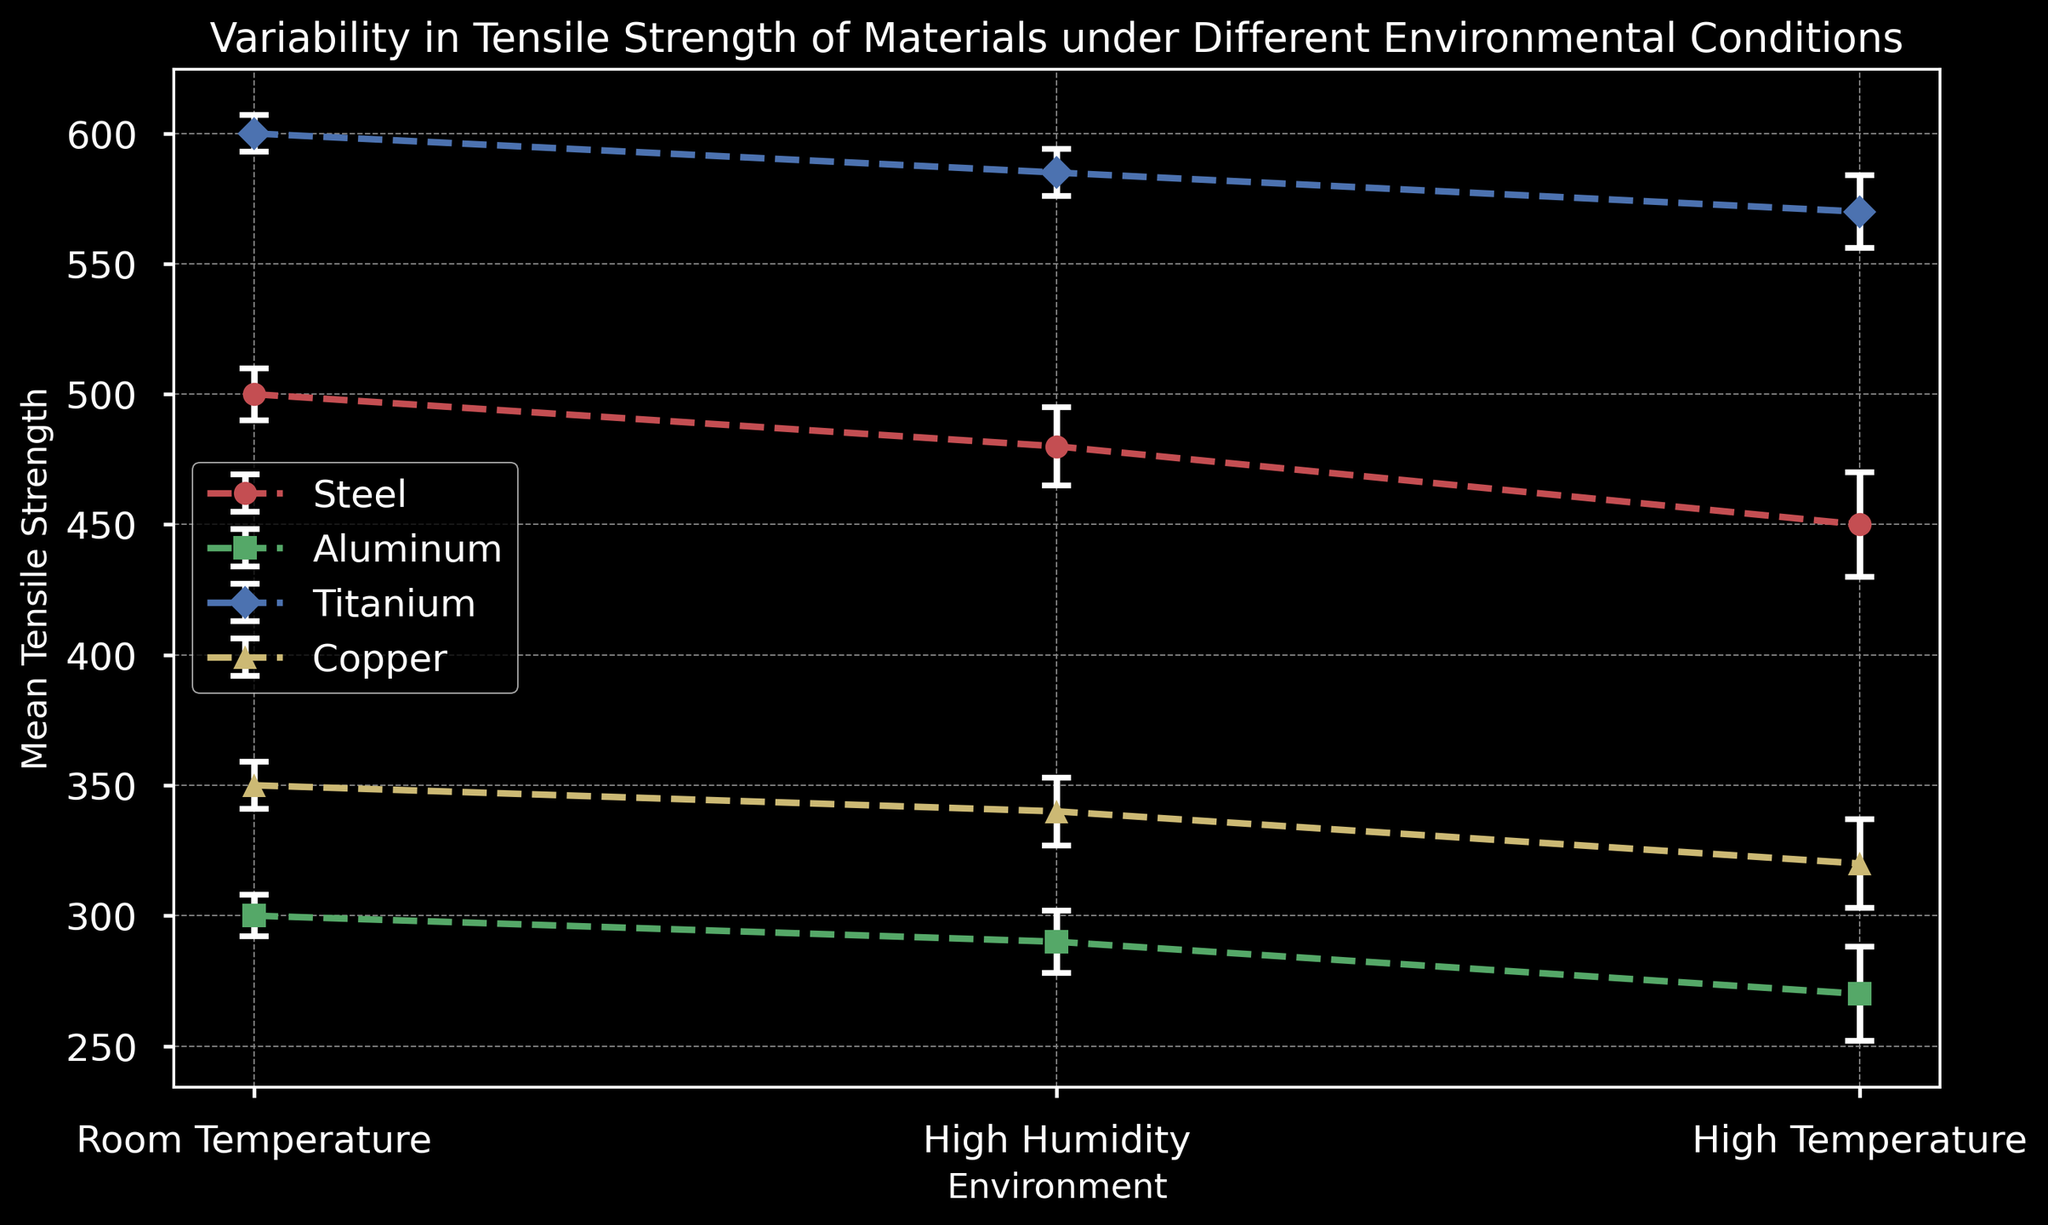What material has the highest variability in tensile strength under high temperature conditions? Variability is measured by the standard deviation. For high temperature conditions: Steel (20), Aluminum (18), Titanium (14), and Copper (17). The material with the highest standard deviation is Steel.
Answer: Steel Which material shows the least drop in mean tensile strength from room temperature to high humidity? Calculate the difference for each material: Steel (500-480=20), Aluminum (300-290=10), Titanium (600-585=15), and Copper (350-340=10). Aluminum and Copper both show the smallest drop of 10.
Answer: Aluminum, Copper Between Steel and Titanium, which material has a higher average tensile strength under all conditions? Calculate the average tensile strength for each condition for both materials: Steel (500+480+450)/3 = 476.67, Titanium (600+585+570)/3 = 585. Titanium has a higher average tensile strength.
Answer: Titanium Which environment has the most consistent tensile strength for Aluminum? Consistency is shown by the smallest standard deviation. For Aluminum: Room Temperature (8), High Humidity (12), High Temperature (18). The smallest standard deviation is under Room Temperature with 8.
Answer: Room Temperature How does the tensile strength of Copper at high temperature compare to Steel at high humidity? Compare the mean tensile strength values directly: Copper at high temperature is 320, Steel at high humidity is 480. Copper's tensile strength is lower.
Answer: Copper is lower What is the total standard deviation for Titanium across all conditions? Sum the standard deviation values for Titanium: 7 (Room Temperature) + 9 (High Humidity) + 14 (High Temperature) = 30.
Answer: 30 In which environmental condition do all materials exhibit the highest mean tensile strength? Check the mean values for all conditions: Room Temperature for Steel (500), Aluminum (300), Titanium (600), Copper (350). High Humidity and High Temperature have lower values for most materials.
Answer: Room Temperature Which material shows the smallest variability in tensile strength under high humidity? Compare the standard deviation values under high humidity: Steel (15), Aluminum (12), Titanium (9), Copper (13). Titanium has the smallest standard deviation of 9.
Answer: Titanium If you average the tensile strength for all materials under high temperature, what would it be? Add the mean tensile strength for all materials under high temperature and divide by the number of materials: (450+270+570+320)/4 = 402.5.
Answer: 402.5 How does the variability in tensile strength for Aluminum change from room temperature to high temperature? Calculate the difference in standard deviation: Room Temperature (8), High Temperature (18). The change is 18 - 8 = 10.
Answer: Variability increases by 10 